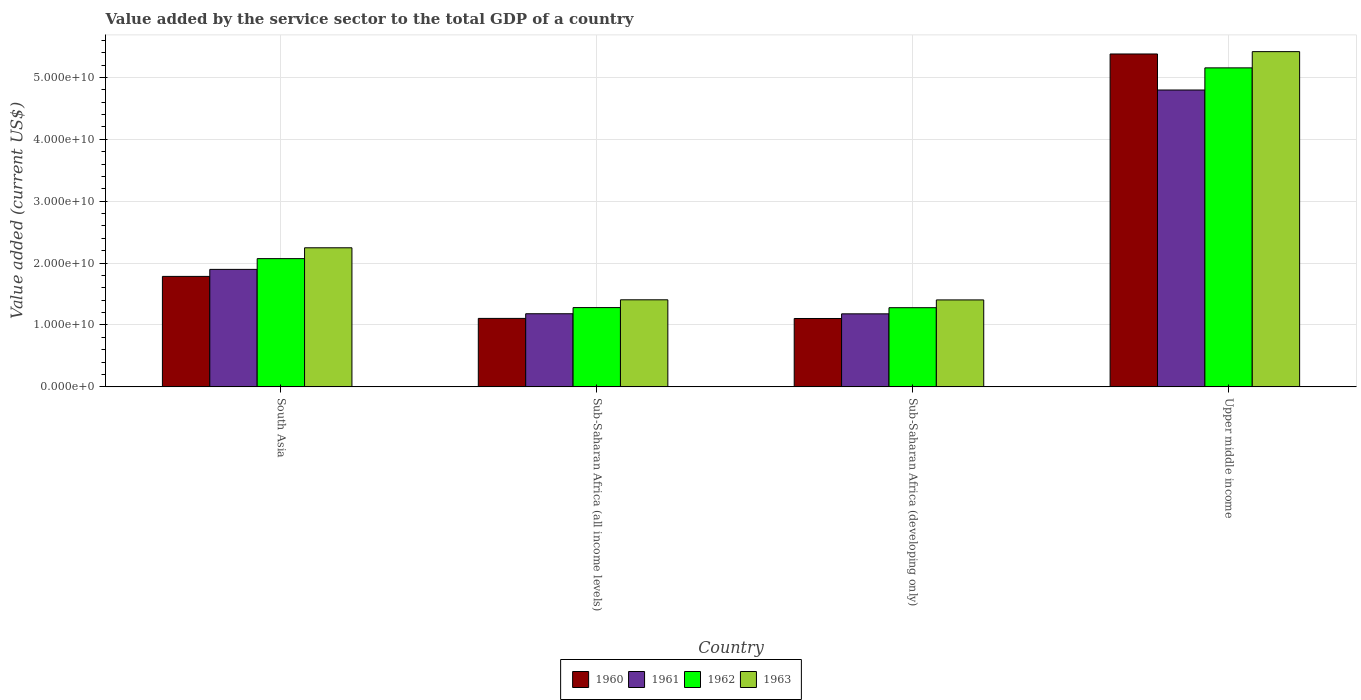How many different coloured bars are there?
Provide a succinct answer. 4. How many groups of bars are there?
Offer a terse response. 4. How many bars are there on the 2nd tick from the left?
Your response must be concise. 4. How many bars are there on the 2nd tick from the right?
Offer a very short reply. 4. In how many cases, is the number of bars for a given country not equal to the number of legend labels?
Your answer should be compact. 0. What is the value added by the service sector to the total GDP in 1963 in Sub-Saharan Africa (developing only)?
Your answer should be compact. 1.41e+1. Across all countries, what is the maximum value added by the service sector to the total GDP in 1961?
Make the answer very short. 4.80e+1. Across all countries, what is the minimum value added by the service sector to the total GDP in 1960?
Offer a terse response. 1.10e+1. In which country was the value added by the service sector to the total GDP in 1960 maximum?
Keep it short and to the point. Upper middle income. In which country was the value added by the service sector to the total GDP in 1963 minimum?
Your answer should be compact. Sub-Saharan Africa (developing only). What is the total value added by the service sector to the total GDP in 1963 in the graph?
Your answer should be compact. 1.05e+11. What is the difference between the value added by the service sector to the total GDP in 1960 in South Asia and that in Sub-Saharan Africa (developing only)?
Your answer should be compact. 6.80e+09. What is the difference between the value added by the service sector to the total GDP in 1961 in South Asia and the value added by the service sector to the total GDP in 1963 in Sub-Saharan Africa (developing only)?
Offer a very short reply. 4.93e+09. What is the average value added by the service sector to the total GDP in 1960 per country?
Your answer should be very brief. 2.34e+1. What is the difference between the value added by the service sector to the total GDP of/in 1962 and value added by the service sector to the total GDP of/in 1961 in South Asia?
Ensure brevity in your answer.  1.74e+09. In how many countries, is the value added by the service sector to the total GDP in 1963 greater than 26000000000 US$?
Your answer should be very brief. 1. What is the ratio of the value added by the service sector to the total GDP in 1963 in Sub-Saharan Africa (developing only) to that in Upper middle income?
Keep it short and to the point. 0.26. Is the value added by the service sector to the total GDP in 1960 in South Asia less than that in Sub-Saharan Africa (developing only)?
Provide a succinct answer. No. What is the difference between the highest and the second highest value added by the service sector to the total GDP in 1961?
Offer a very short reply. -3.62e+1. What is the difference between the highest and the lowest value added by the service sector to the total GDP in 1963?
Your response must be concise. 4.01e+1. Is the sum of the value added by the service sector to the total GDP in 1961 in Sub-Saharan Africa (all income levels) and Upper middle income greater than the maximum value added by the service sector to the total GDP in 1960 across all countries?
Ensure brevity in your answer.  Yes. Is it the case that in every country, the sum of the value added by the service sector to the total GDP in 1960 and value added by the service sector to the total GDP in 1962 is greater than the sum of value added by the service sector to the total GDP in 1963 and value added by the service sector to the total GDP in 1961?
Offer a terse response. No. What does the 3rd bar from the right in Sub-Saharan Africa (all income levels) represents?
Provide a short and direct response. 1961. Is it the case that in every country, the sum of the value added by the service sector to the total GDP in 1963 and value added by the service sector to the total GDP in 1961 is greater than the value added by the service sector to the total GDP in 1960?
Keep it short and to the point. Yes. How many bars are there?
Keep it short and to the point. 16. Are all the bars in the graph horizontal?
Provide a short and direct response. No. Are the values on the major ticks of Y-axis written in scientific E-notation?
Your answer should be compact. Yes. What is the title of the graph?
Your answer should be very brief. Value added by the service sector to the total GDP of a country. What is the label or title of the Y-axis?
Ensure brevity in your answer.  Value added (current US$). What is the Value added (current US$) in 1960 in South Asia?
Your response must be concise. 1.79e+1. What is the Value added (current US$) of 1961 in South Asia?
Your answer should be very brief. 1.90e+1. What is the Value added (current US$) in 1962 in South Asia?
Offer a terse response. 2.07e+1. What is the Value added (current US$) in 1963 in South Asia?
Your response must be concise. 2.25e+1. What is the Value added (current US$) in 1960 in Sub-Saharan Africa (all income levels)?
Provide a succinct answer. 1.11e+1. What is the Value added (current US$) of 1961 in Sub-Saharan Africa (all income levels)?
Offer a very short reply. 1.18e+1. What is the Value added (current US$) in 1962 in Sub-Saharan Africa (all income levels)?
Make the answer very short. 1.28e+1. What is the Value added (current US$) of 1963 in Sub-Saharan Africa (all income levels)?
Offer a terse response. 1.41e+1. What is the Value added (current US$) of 1960 in Sub-Saharan Africa (developing only)?
Provide a short and direct response. 1.10e+1. What is the Value added (current US$) in 1961 in Sub-Saharan Africa (developing only)?
Your answer should be compact. 1.18e+1. What is the Value added (current US$) of 1962 in Sub-Saharan Africa (developing only)?
Offer a terse response. 1.28e+1. What is the Value added (current US$) of 1963 in Sub-Saharan Africa (developing only)?
Offer a very short reply. 1.41e+1. What is the Value added (current US$) of 1960 in Upper middle income?
Provide a short and direct response. 5.38e+1. What is the Value added (current US$) of 1961 in Upper middle income?
Provide a short and direct response. 4.80e+1. What is the Value added (current US$) in 1962 in Upper middle income?
Your response must be concise. 5.16e+1. What is the Value added (current US$) of 1963 in Upper middle income?
Offer a very short reply. 5.42e+1. Across all countries, what is the maximum Value added (current US$) of 1960?
Make the answer very short. 5.38e+1. Across all countries, what is the maximum Value added (current US$) in 1961?
Provide a short and direct response. 4.80e+1. Across all countries, what is the maximum Value added (current US$) in 1962?
Offer a terse response. 5.16e+1. Across all countries, what is the maximum Value added (current US$) of 1963?
Keep it short and to the point. 5.42e+1. Across all countries, what is the minimum Value added (current US$) in 1960?
Your answer should be compact. 1.10e+1. Across all countries, what is the minimum Value added (current US$) of 1961?
Keep it short and to the point. 1.18e+1. Across all countries, what is the minimum Value added (current US$) in 1962?
Offer a very short reply. 1.28e+1. Across all countries, what is the minimum Value added (current US$) of 1963?
Your answer should be very brief. 1.41e+1. What is the total Value added (current US$) in 1960 in the graph?
Your answer should be very brief. 9.38e+1. What is the total Value added (current US$) in 1961 in the graph?
Your response must be concise. 9.06e+1. What is the total Value added (current US$) in 1962 in the graph?
Give a very brief answer. 9.79e+1. What is the total Value added (current US$) of 1963 in the graph?
Offer a terse response. 1.05e+11. What is the difference between the Value added (current US$) in 1960 in South Asia and that in Sub-Saharan Africa (all income levels)?
Your answer should be very brief. 6.79e+09. What is the difference between the Value added (current US$) of 1961 in South Asia and that in Sub-Saharan Africa (all income levels)?
Your answer should be compact. 7.17e+09. What is the difference between the Value added (current US$) of 1962 in South Asia and that in Sub-Saharan Africa (all income levels)?
Make the answer very short. 7.91e+09. What is the difference between the Value added (current US$) of 1963 in South Asia and that in Sub-Saharan Africa (all income levels)?
Your response must be concise. 8.41e+09. What is the difference between the Value added (current US$) in 1960 in South Asia and that in Sub-Saharan Africa (developing only)?
Ensure brevity in your answer.  6.80e+09. What is the difference between the Value added (current US$) of 1961 in South Asia and that in Sub-Saharan Africa (developing only)?
Keep it short and to the point. 7.18e+09. What is the difference between the Value added (current US$) of 1962 in South Asia and that in Sub-Saharan Africa (developing only)?
Provide a short and direct response. 7.93e+09. What is the difference between the Value added (current US$) in 1963 in South Asia and that in Sub-Saharan Africa (developing only)?
Provide a short and direct response. 8.42e+09. What is the difference between the Value added (current US$) of 1960 in South Asia and that in Upper middle income?
Your answer should be compact. -3.59e+1. What is the difference between the Value added (current US$) in 1961 in South Asia and that in Upper middle income?
Keep it short and to the point. -2.90e+1. What is the difference between the Value added (current US$) of 1962 in South Asia and that in Upper middle income?
Make the answer very short. -3.08e+1. What is the difference between the Value added (current US$) in 1963 in South Asia and that in Upper middle income?
Give a very brief answer. -3.17e+1. What is the difference between the Value added (current US$) in 1960 in Sub-Saharan Africa (all income levels) and that in Sub-Saharan Africa (developing only)?
Keep it short and to the point. 1.42e+07. What is the difference between the Value added (current US$) of 1961 in Sub-Saharan Africa (all income levels) and that in Sub-Saharan Africa (developing only)?
Offer a very short reply. 1.52e+07. What is the difference between the Value added (current US$) of 1962 in Sub-Saharan Africa (all income levels) and that in Sub-Saharan Africa (developing only)?
Provide a short and direct response. 1.65e+07. What is the difference between the Value added (current US$) in 1963 in Sub-Saharan Africa (all income levels) and that in Sub-Saharan Africa (developing only)?
Offer a terse response. 1.81e+07. What is the difference between the Value added (current US$) in 1960 in Sub-Saharan Africa (all income levels) and that in Upper middle income?
Keep it short and to the point. -4.27e+1. What is the difference between the Value added (current US$) of 1961 in Sub-Saharan Africa (all income levels) and that in Upper middle income?
Keep it short and to the point. -3.62e+1. What is the difference between the Value added (current US$) in 1962 in Sub-Saharan Africa (all income levels) and that in Upper middle income?
Provide a succinct answer. -3.87e+1. What is the difference between the Value added (current US$) in 1963 in Sub-Saharan Africa (all income levels) and that in Upper middle income?
Keep it short and to the point. -4.01e+1. What is the difference between the Value added (current US$) in 1960 in Sub-Saharan Africa (developing only) and that in Upper middle income?
Give a very brief answer. -4.27e+1. What is the difference between the Value added (current US$) of 1961 in Sub-Saharan Africa (developing only) and that in Upper middle income?
Ensure brevity in your answer.  -3.62e+1. What is the difference between the Value added (current US$) in 1962 in Sub-Saharan Africa (developing only) and that in Upper middle income?
Your answer should be compact. -3.88e+1. What is the difference between the Value added (current US$) of 1963 in Sub-Saharan Africa (developing only) and that in Upper middle income?
Offer a terse response. -4.01e+1. What is the difference between the Value added (current US$) in 1960 in South Asia and the Value added (current US$) in 1961 in Sub-Saharan Africa (all income levels)?
Ensure brevity in your answer.  6.03e+09. What is the difference between the Value added (current US$) of 1960 in South Asia and the Value added (current US$) of 1962 in Sub-Saharan Africa (all income levels)?
Keep it short and to the point. 5.04e+09. What is the difference between the Value added (current US$) of 1960 in South Asia and the Value added (current US$) of 1963 in Sub-Saharan Africa (all income levels)?
Keep it short and to the point. 3.78e+09. What is the difference between the Value added (current US$) in 1961 in South Asia and the Value added (current US$) in 1962 in Sub-Saharan Africa (all income levels)?
Provide a succinct answer. 6.17e+09. What is the difference between the Value added (current US$) in 1961 in South Asia and the Value added (current US$) in 1963 in Sub-Saharan Africa (all income levels)?
Your response must be concise. 4.91e+09. What is the difference between the Value added (current US$) of 1962 in South Asia and the Value added (current US$) of 1963 in Sub-Saharan Africa (all income levels)?
Your answer should be very brief. 6.65e+09. What is the difference between the Value added (current US$) in 1960 in South Asia and the Value added (current US$) in 1961 in Sub-Saharan Africa (developing only)?
Ensure brevity in your answer.  6.05e+09. What is the difference between the Value added (current US$) of 1960 in South Asia and the Value added (current US$) of 1962 in Sub-Saharan Africa (developing only)?
Offer a very short reply. 5.06e+09. What is the difference between the Value added (current US$) in 1960 in South Asia and the Value added (current US$) in 1963 in Sub-Saharan Africa (developing only)?
Your answer should be compact. 3.80e+09. What is the difference between the Value added (current US$) in 1961 in South Asia and the Value added (current US$) in 1962 in Sub-Saharan Africa (developing only)?
Offer a very short reply. 6.19e+09. What is the difference between the Value added (current US$) of 1961 in South Asia and the Value added (current US$) of 1963 in Sub-Saharan Africa (developing only)?
Your answer should be compact. 4.93e+09. What is the difference between the Value added (current US$) of 1962 in South Asia and the Value added (current US$) of 1963 in Sub-Saharan Africa (developing only)?
Your answer should be very brief. 6.67e+09. What is the difference between the Value added (current US$) of 1960 in South Asia and the Value added (current US$) of 1961 in Upper middle income?
Your response must be concise. -3.01e+1. What is the difference between the Value added (current US$) in 1960 in South Asia and the Value added (current US$) in 1962 in Upper middle income?
Your response must be concise. -3.37e+1. What is the difference between the Value added (current US$) of 1960 in South Asia and the Value added (current US$) of 1963 in Upper middle income?
Your response must be concise. -3.63e+1. What is the difference between the Value added (current US$) of 1961 in South Asia and the Value added (current US$) of 1962 in Upper middle income?
Give a very brief answer. -3.26e+1. What is the difference between the Value added (current US$) in 1961 in South Asia and the Value added (current US$) in 1963 in Upper middle income?
Your answer should be compact. -3.52e+1. What is the difference between the Value added (current US$) in 1962 in South Asia and the Value added (current US$) in 1963 in Upper middle income?
Offer a very short reply. -3.34e+1. What is the difference between the Value added (current US$) in 1960 in Sub-Saharan Africa (all income levels) and the Value added (current US$) in 1961 in Sub-Saharan Africa (developing only)?
Provide a succinct answer. -7.38e+08. What is the difference between the Value added (current US$) of 1960 in Sub-Saharan Africa (all income levels) and the Value added (current US$) of 1962 in Sub-Saharan Africa (developing only)?
Keep it short and to the point. -1.73e+09. What is the difference between the Value added (current US$) of 1960 in Sub-Saharan Africa (all income levels) and the Value added (current US$) of 1963 in Sub-Saharan Africa (developing only)?
Offer a very short reply. -2.99e+09. What is the difference between the Value added (current US$) in 1961 in Sub-Saharan Africa (all income levels) and the Value added (current US$) in 1962 in Sub-Saharan Africa (developing only)?
Give a very brief answer. -9.78e+08. What is the difference between the Value added (current US$) in 1961 in Sub-Saharan Africa (all income levels) and the Value added (current US$) in 1963 in Sub-Saharan Africa (developing only)?
Make the answer very short. -2.23e+09. What is the difference between the Value added (current US$) of 1962 in Sub-Saharan Africa (all income levels) and the Value added (current US$) of 1963 in Sub-Saharan Africa (developing only)?
Offer a terse response. -1.24e+09. What is the difference between the Value added (current US$) of 1960 in Sub-Saharan Africa (all income levels) and the Value added (current US$) of 1961 in Upper middle income?
Your response must be concise. -3.69e+1. What is the difference between the Value added (current US$) of 1960 in Sub-Saharan Africa (all income levels) and the Value added (current US$) of 1962 in Upper middle income?
Your answer should be very brief. -4.05e+1. What is the difference between the Value added (current US$) of 1960 in Sub-Saharan Africa (all income levels) and the Value added (current US$) of 1963 in Upper middle income?
Keep it short and to the point. -4.31e+1. What is the difference between the Value added (current US$) of 1961 in Sub-Saharan Africa (all income levels) and the Value added (current US$) of 1962 in Upper middle income?
Your response must be concise. -3.97e+1. What is the difference between the Value added (current US$) of 1961 in Sub-Saharan Africa (all income levels) and the Value added (current US$) of 1963 in Upper middle income?
Offer a very short reply. -4.24e+1. What is the difference between the Value added (current US$) in 1962 in Sub-Saharan Africa (all income levels) and the Value added (current US$) in 1963 in Upper middle income?
Your answer should be compact. -4.14e+1. What is the difference between the Value added (current US$) in 1960 in Sub-Saharan Africa (developing only) and the Value added (current US$) in 1961 in Upper middle income?
Keep it short and to the point. -3.69e+1. What is the difference between the Value added (current US$) in 1960 in Sub-Saharan Africa (developing only) and the Value added (current US$) in 1962 in Upper middle income?
Offer a terse response. -4.05e+1. What is the difference between the Value added (current US$) in 1960 in Sub-Saharan Africa (developing only) and the Value added (current US$) in 1963 in Upper middle income?
Your answer should be very brief. -4.31e+1. What is the difference between the Value added (current US$) of 1961 in Sub-Saharan Africa (developing only) and the Value added (current US$) of 1962 in Upper middle income?
Make the answer very short. -3.97e+1. What is the difference between the Value added (current US$) of 1961 in Sub-Saharan Africa (developing only) and the Value added (current US$) of 1963 in Upper middle income?
Offer a terse response. -4.24e+1. What is the difference between the Value added (current US$) in 1962 in Sub-Saharan Africa (developing only) and the Value added (current US$) in 1963 in Upper middle income?
Provide a succinct answer. -4.14e+1. What is the average Value added (current US$) in 1960 per country?
Your response must be concise. 2.34e+1. What is the average Value added (current US$) in 1961 per country?
Ensure brevity in your answer.  2.26e+1. What is the average Value added (current US$) in 1962 per country?
Provide a short and direct response. 2.45e+1. What is the average Value added (current US$) in 1963 per country?
Your answer should be compact. 2.62e+1. What is the difference between the Value added (current US$) of 1960 and Value added (current US$) of 1961 in South Asia?
Make the answer very short. -1.13e+09. What is the difference between the Value added (current US$) in 1960 and Value added (current US$) in 1962 in South Asia?
Ensure brevity in your answer.  -2.87e+09. What is the difference between the Value added (current US$) in 1960 and Value added (current US$) in 1963 in South Asia?
Keep it short and to the point. -4.62e+09. What is the difference between the Value added (current US$) of 1961 and Value added (current US$) of 1962 in South Asia?
Keep it short and to the point. -1.74e+09. What is the difference between the Value added (current US$) in 1961 and Value added (current US$) in 1963 in South Asia?
Offer a very short reply. -3.49e+09. What is the difference between the Value added (current US$) in 1962 and Value added (current US$) in 1963 in South Asia?
Your answer should be very brief. -1.75e+09. What is the difference between the Value added (current US$) of 1960 and Value added (current US$) of 1961 in Sub-Saharan Africa (all income levels)?
Keep it short and to the point. -7.53e+08. What is the difference between the Value added (current US$) of 1960 and Value added (current US$) of 1962 in Sub-Saharan Africa (all income levels)?
Your answer should be very brief. -1.75e+09. What is the difference between the Value added (current US$) of 1960 and Value added (current US$) of 1963 in Sub-Saharan Africa (all income levels)?
Your answer should be compact. -3.01e+09. What is the difference between the Value added (current US$) of 1961 and Value added (current US$) of 1962 in Sub-Saharan Africa (all income levels)?
Offer a terse response. -9.94e+08. What is the difference between the Value added (current US$) in 1961 and Value added (current US$) in 1963 in Sub-Saharan Africa (all income levels)?
Your answer should be compact. -2.25e+09. What is the difference between the Value added (current US$) of 1962 and Value added (current US$) of 1963 in Sub-Saharan Africa (all income levels)?
Your answer should be compact. -1.26e+09. What is the difference between the Value added (current US$) of 1960 and Value added (current US$) of 1961 in Sub-Saharan Africa (developing only)?
Your answer should be compact. -7.52e+08. What is the difference between the Value added (current US$) in 1960 and Value added (current US$) in 1962 in Sub-Saharan Africa (developing only)?
Your answer should be compact. -1.75e+09. What is the difference between the Value added (current US$) of 1960 and Value added (current US$) of 1963 in Sub-Saharan Africa (developing only)?
Your answer should be compact. -3.00e+09. What is the difference between the Value added (current US$) in 1961 and Value added (current US$) in 1962 in Sub-Saharan Africa (developing only)?
Ensure brevity in your answer.  -9.93e+08. What is the difference between the Value added (current US$) of 1961 and Value added (current US$) of 1963 in Sub-Saharan Africa (developing only)?
Offer a terse response. -2.25e+09. What is the difference between the Value added (current US$) of 1962 and Value added (current US$) of 1963 in Sub-Saharan Africa (developing only)?
Make the answer very short. -1.26e+09. What is the difference between the Value added (current US$) in 1960 and Value added (current US$) in 1961 in Upper middle income?
Provide a short and direct response. 5.82e+09. What is the difference between the Value added (current US$) in 1960 and Value added (current US$) in 1962 in Upper middle income?
Your response must be concise. 2.24e+09. What is the difference between the Value added (current US$) in 1960 and Value added (current US$) in 1963 in Upper middle income?
Keep it short and to the point. -3.78e+08. What is the difference between the Value added (current US$) in 1961 and Value added (current US$) in 1962 in Upper middle income?
Provide a short and direct response. -3.58e+09. What is the difference between the Value added (current US$) in 1961 and Value added (current US$) in 1963 in Upper middle income?
Give a very brief answer. -6.20e+09. What is the difference between the Value added (current US$) in 1962 and Value added (current US$) in 1963 in Upper middle income?
Give a very brief answer. -2.62e+09. What is the ratio of the Value added (current US$) of 1960 in South Asia to that in Sub-Saharan Africa (all income levels)?
Your response must be concise. 1.61. What is the ratio of the Value added (current US$) in 1961 in South Asia to that in Sub-Saharan Africa (all income levels)?
Offer a very short reply. 1.61. What is the ratio of the Value added (current US$) in 1962 in South Asia to that in Sub-Saharan Africa (all income levels)?
Provide a succinct answer. 1.62. What is the ratio of the Value added (current US$) of 1963 in South Asia to that in Sub-Saharan Africa (all income levels)?
Your response must be concise. 1.6. What is the ratio of the Value added (current US$) of 1960 in South Asia to that in Sub-Saharan Africa (developing only)?
Your answer should be very brief. 1.62. What is the ratio of the Value added (current US$) in 1961 in South Asia to that in Sub-Saharan Africa (developing only)?
Your answer should be very brief. 1.61. What is the ratio of the Value added (current US$) of 1962 in South Asia to that in Sub-Saharan Africa (developing only)?
Provide a short and direct response. 1.62. What is the ratio of the Value added (current US$) in 1963 in South Asia to that in Sub-Saharan Africa (developing only)?
Offer a very short reply. 1.6. What is the ratio of the Value added (current US$) of 1960 in South Asia to that in Upper middle income?
Your answer should be compact. 0.33. What is the ratio of the Value added (current US$) of 1961 in South Asia to that in Upper middle income?
Your answer should be very brief. 0.4. What is the ratio of the Value added (current US$) in 1962 in South Asia to that in Upper middle income?
Keep it short and to the point. 0.4. What is the ratio of the Value added (current US$) in 1963 in South Asia to that in Upper middle income?
Your response must be concise. 0.41. What is the ratio of the Value added (current US$) in 1960 in Sub-Saharan Africa (all income levels) to that in Sub-Saharan Africa (developing only)?
Give a very brief answer. 1. What is the ratio of the Value added (current US$) of 1961 in Sub-Saharan Africa (all income levels) to that in Sub-Saharan Africa (developing only)?
Make the answer very short. 1. What is the ratio of the Value added (current US$) of 1960 in Sub-Saharan Africa (all income levels) to that in Upper middle income?
Make the answer very short. 0.21. What is the ratio of the Value added (current US$) of 1961 in Sub-Saharan Africa (all income levels) to that in Upper middle income?
Give a very brief answer. 0.25. What is the ratio of the Value added (current US$) of 1962 in Sub-Saharan Africa (all income levels) to that in Upper middle income?
Your response must be concise. 0.25. What is the ratio of the Value added (current US$) in 1963 in Sub-Saharan Africa (all income levels) to that in Upper middle income?
Provide a succinct answer. 0.26. What is the ratio of the Value added (current US$) of 1960 in Sub-Saharan Africa (developing only) to that in Upper middle income?
Offer a very short reply. 0.21. What is the ratio of the Value added (current US$) of 1961 in Sub-Saharan Africa (developing only) to that in Upper middle income?
Your response must be concise. 0.25. What is the ratio of the Value added (current US$) of 1962 in Sub-Saharan Africa (developing only) to that in Upper middle income?
Provide a short and direct response. 0.25. What is the ratio of the Value added (current US$) in 1963 in Sub-Saharan Africa (developing only) to that in Upper middle income?
Your answer should be very brief. 0.26. What is the difference between the highest and the second highest Value added (current US$) in 1960?
Ensure brevity in your answer.  3.59e+1. What is the difference between the highest and the second highest Value added (current US$) of 1961?
Provide a short and direct response. 2.90e+1. What is the difference between the highest and the second highest Value added (current US$) of 1962?
Give a very brief answer. 3.08e+1. What is the difference between the highest and the second highest Value added (current US$) of 1963?
Offer a very short reply. 3.17e+1. What is the difference between the highest and the lowest Value added (current US$) of 1960?
Ensure brevity in your answer.  4.27e+1. What is the difference between the highest and the lowest Value added (current US$) in 1961?
Offer a very short reply. 3.62e+1. What is the difference between the highest and the lowest Value added (current US$) of 1962?
Ensure brevity in your answer.  3.88e+1. What is the difference between the highest and the lowest Value added (current US$) in 1963?
Offer a very short reply. 4.01e+1. 